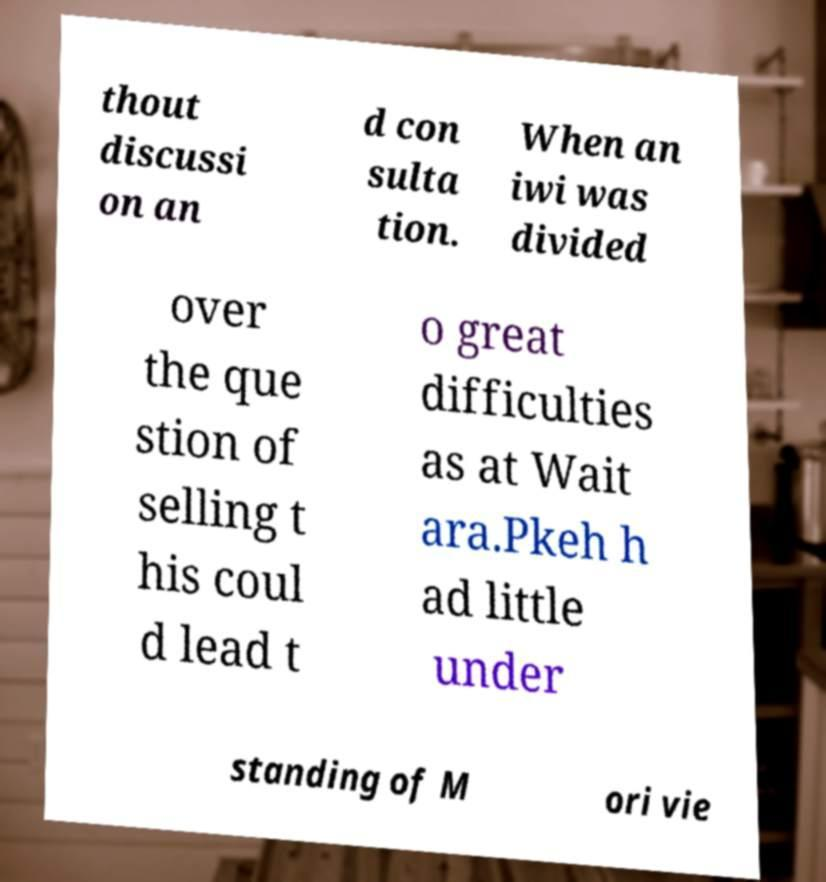Please read and relay the text visible in this image. What does it say? thout discussi on an d con sulta tion. When an iwi was divided over the que stion of selling t his coul d lead t o great difficulties as at Wait ara.Pkeh h ad little under standing of M ori vie 